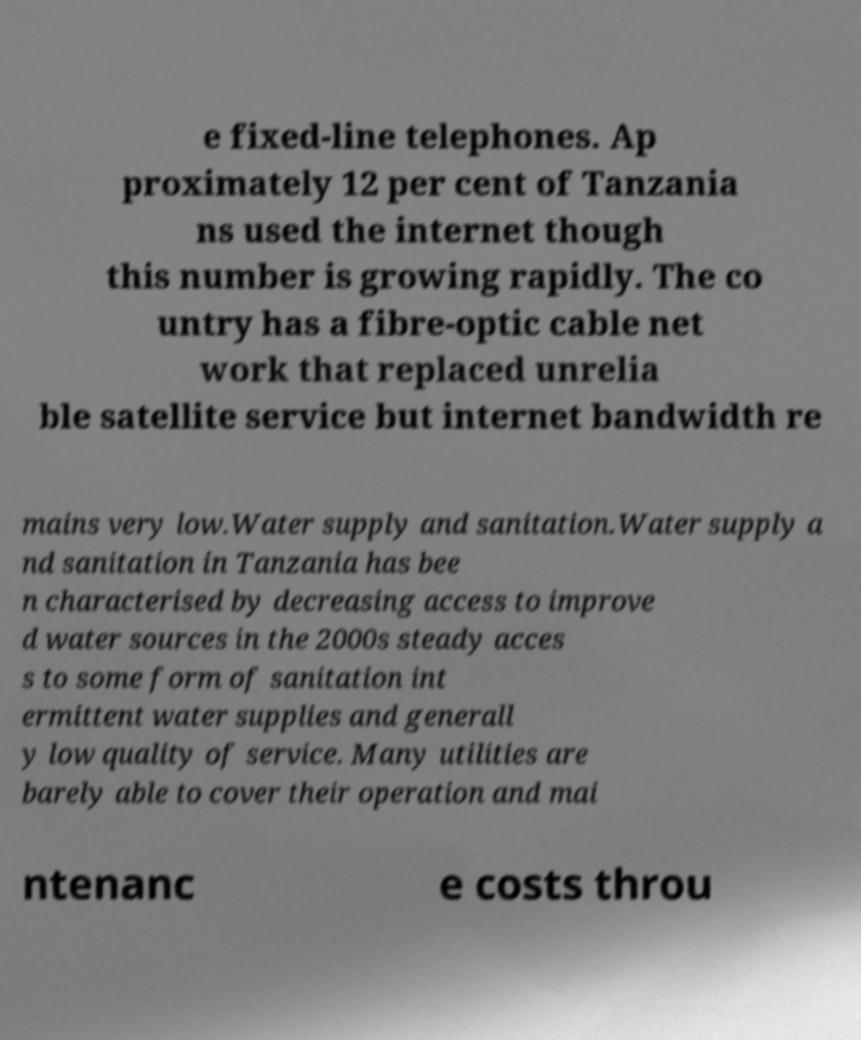Could you extract and type out the text from this image? e fixed-line telephones. Ap proximately 12 per cent of Tanzania ns used the internet though this number is growing rapidly. The co untry has a fibre-optic cable net work that replaced unrelia ble satellite service but internet bandwidth re mains very low.Water supply and sanitation.Water supply a nd sanitation in Tanzania has bee n characterised by decreasing access to improve d water sources in the 2000s steady acces s to some form of sanitation int ermittent water supplies and generall y low quality of service. Many utilities are barely able to cover their operation and mai ntenanc e costs throu 